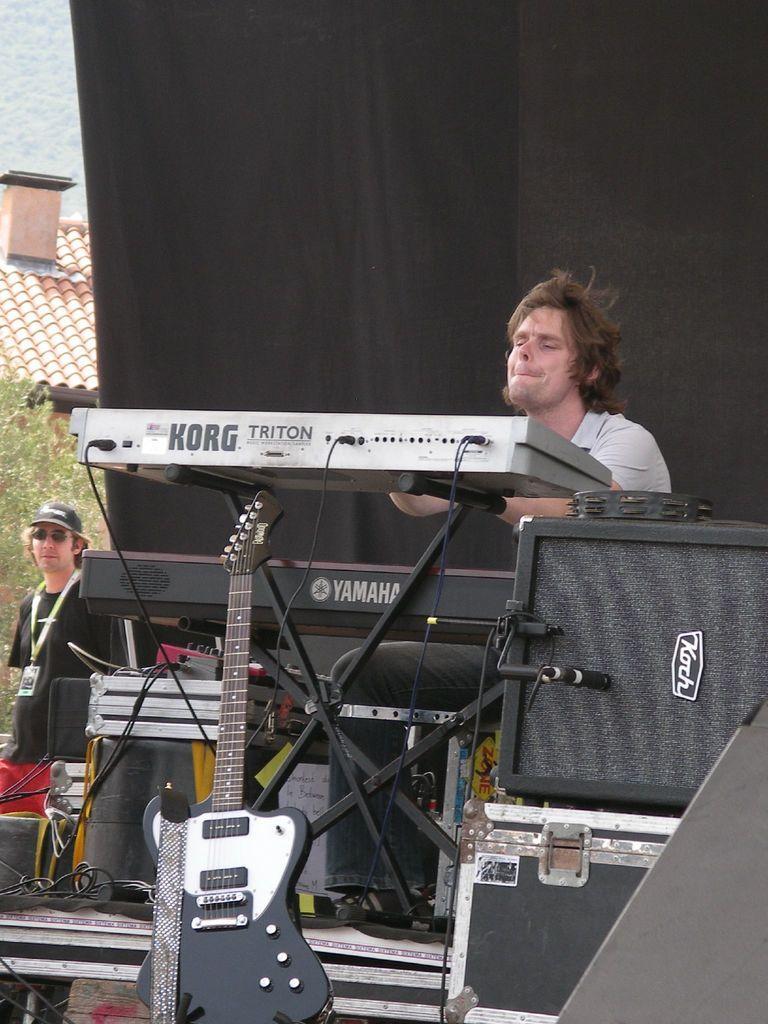Please provide a concise description of this image. In the front of the image a person is sitting, in-front of that person there are musical instruments, device, box, guitar and objects. In the background I can see a person, black curtain, house and tree. Another person is standing, wore ID card and wore a cap. 